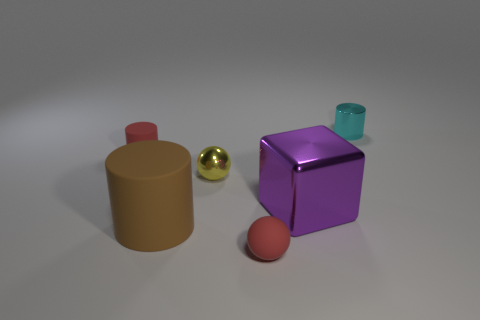How many objects are there in total in the image? There are five objects in the image. Can you describe the texture of the purple object? The purple object appears to have a smooth, shiny texture which gives it a reflective surface. 